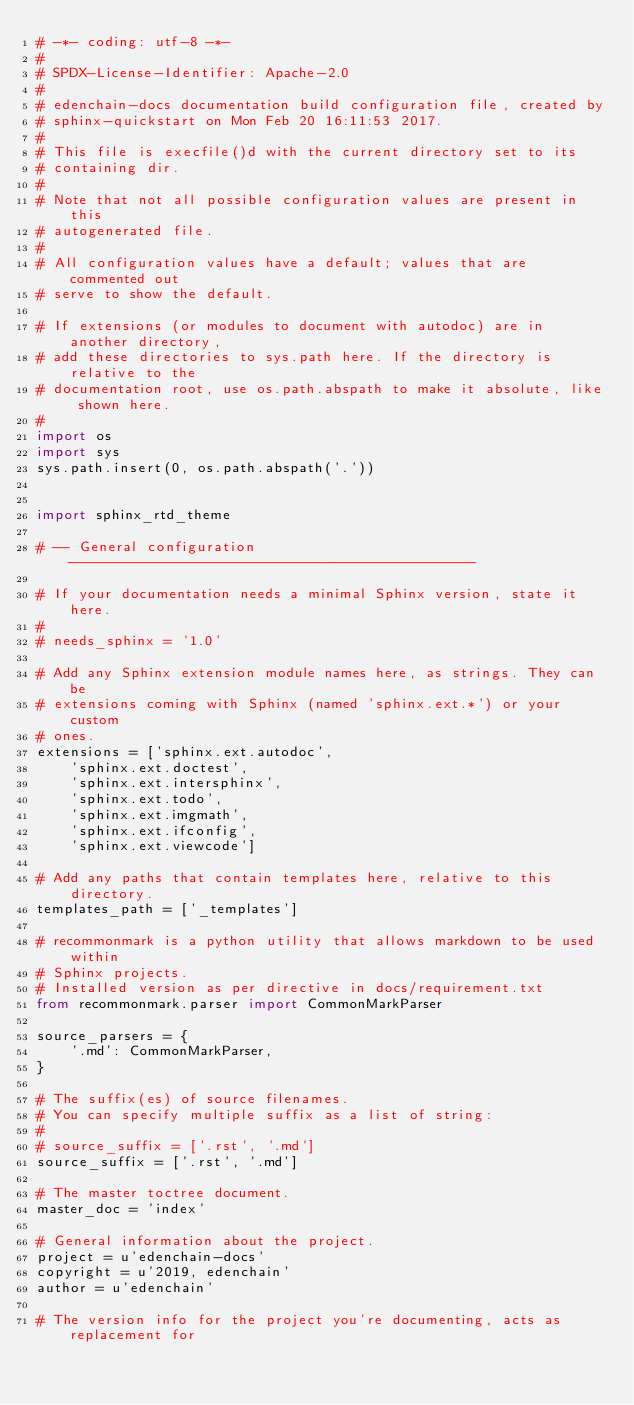<code> <loc_0><loc_0><loc_500><loc_500><_Python_># -*- coding: utf-8 -*-
#
# SPDX-License-Identifier: Apache-2.0
#
# edenchain-docs documentation build configuration file, created by
# sphinx-quickstart on Mon Feb 20 16:11:53 2017.
#
# This file is execfile()d with the current directory set to its
# containing dir.
#
# Note that not all possible configuration values are present in this
# autogenerated file.
#
# All configuration values have a default; values that are commented out
# serve to show the default.

# If extensions (or modules to document with autodoc) are in another directory,
# add these directories to sys.path here. If the directory is relative to the
# documentation root, use os.path.abspath to make it absolute, like shown here.
#
import os
import sys
sys.path.insert(0, os.path.abspath('.'))


import sphinx_rtd_theme

# -- General configuration ------------------------------------------------

# If your documentation needs a minimal Sphinx version, state it here.
#
# needs_sphinx = '1.0'

# Add any Sphinx extension module names here, as strings. They can be
# extensions coming with Sphinx (named 'sphinx.ext.*') or your custom
# ones.
extensions = ['sphinx.ext.autodoc',
    'sphinx.ext.doctest',
    'sphinx.ext.intersphinx',
    'sphinx.ext.todo',
    'sphinx.ext.imgmath',
    'sphinx.ext.ifconfig',
    'sphinx.ext.viewcode']

# Add any paths that contain templates here, relative to this directory.
templates_path = ['_templates']

# recommonmark is a python utility that allows markdown to be used within
# Sphinx projects.
# Installed version as per directive in docs/requirement.txt
from recommonmark.parser import CommonMarkParser

source_parsers = {
    '.md': CommonMarkParser,
}

# The suffix(es) of source filenames.
# You can specify multiple suffix as a list of string:
#
# source_suffix = ['.rst', '.md']
source_suffix = ['.rst', '.md']

# The master toctree document.
master_doc = 'index'

# General information about the project.
project = u'edenchain-docs'
copyright = u'2019, edenchain'
author = u'edenchain'

# The version info for the project you're documenting, acts as replacement for</code> 